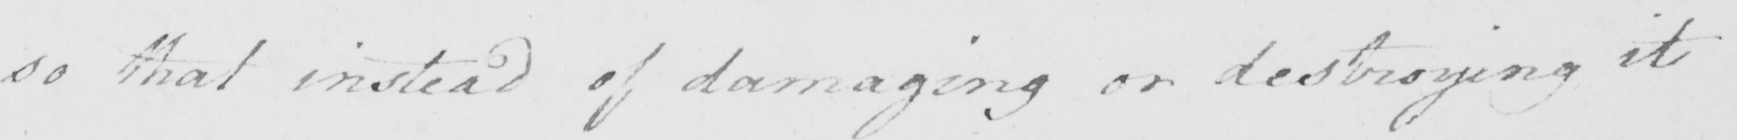What does this handwritten line say? so that instead of damaging or destroying it 